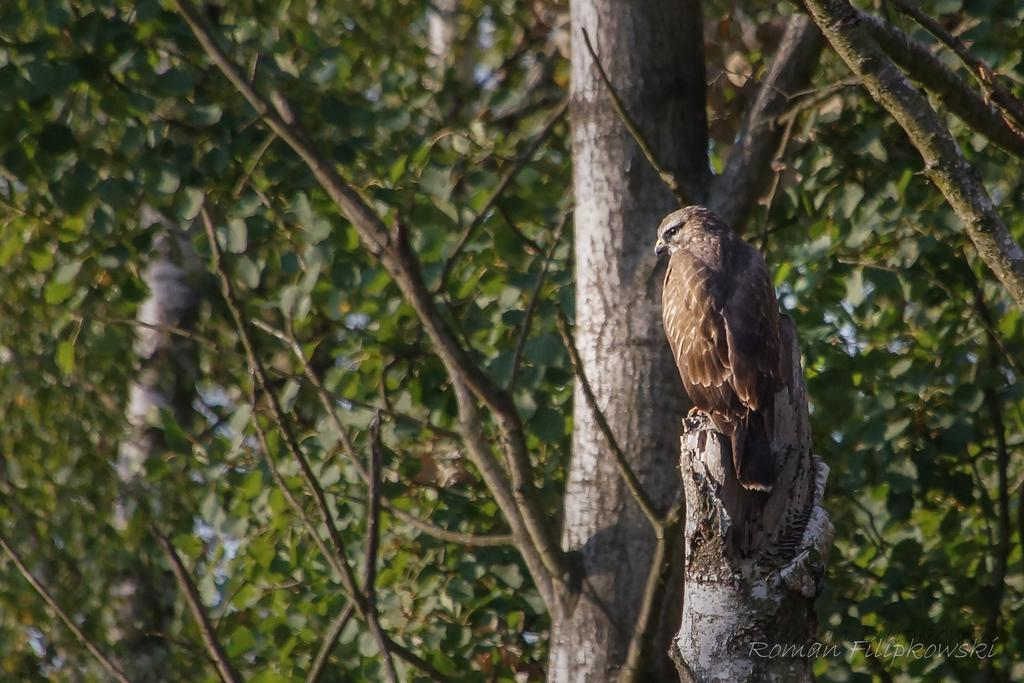What type of animal is present in the image? There is a bird in the image. Where is the bird located in the image? The bird is present on the bark of a tree. Is there any text or symbol at the bottom of the image? Yes, there is a logo at the bottom of the image. How many goats are present in the image? There are no goats present in the image. What type of clothing are the women wearing in the image? There are no women present in the image. 